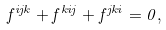Convert formula to latex. <formula><loc_0><loc_0><loc_500><loc_500>f ^ { i j k } + f ^ { k i j } + f ^ { j k i } = 0 ,</formula> 